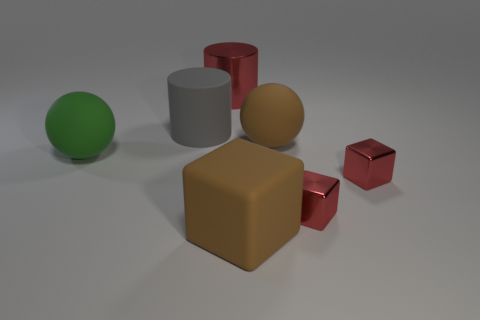Subtract all blue cylinders. How many red cubes are left? 2 Subtract all metal cubes. How many cubes are left? 1 Subtract 1 blocks. How many blocks are left? 2 Add 2 purple shiny cubes. How many objects exist? 9 Subtract all cubes. How many objects are left? 4 Add 7 large brown blocks. How many large brown blocks are left? 8 Add 1 red matte things. How many red matte things exist? 1 Subtract 1 red cylinders. How many objects are left? 6 Subtract all large objects. Subtract all tiny blue metallic balls. How many objects are left? 2 